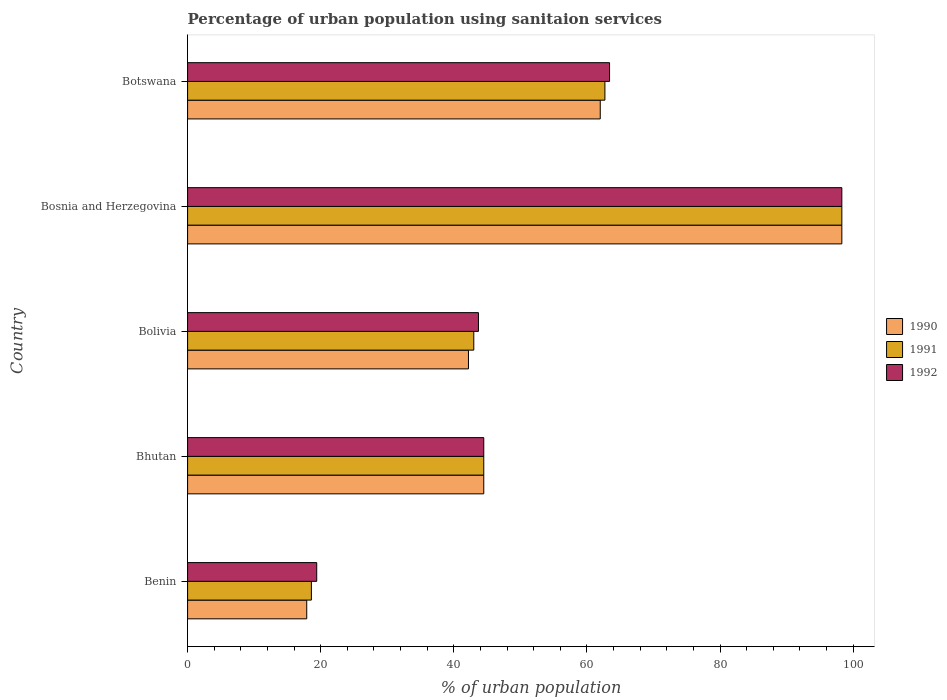How many different coloured bars are there?
Give a very brief answer. 3. Are the number of bars per tick equal to the number of legend labels?
Offer a terse response. Yes. Are the number of bars on each tick of the Y-axis equal?
Your response must be concise. Yes. How many bars are there on the 5th tick from the top?
Your answer should be very brief. 3. How many bars are there on the 2nd tick from the bottom?
Offer a very short reply. 3. What is the label of the 2nd group of bars from the top?
Give a very brief answer. Bosnia and Herzegovina. In how many cases, is the number of bars for a given country not equal to the number of legend labels?
Provide a succinct answer. 0. What is the percentage of urban population using sanitaion services in 1992 in Bosnia and Herzegovina?
Provide a succinct answer. 98.3. Across all countries, what is the maximum percentage of urban population using sanitaion services in 1992?
Your response must be concise. 98.3. Across all countries, what is the minimum percentage of urban population using sanitaion services in 1990?
Offer a very short reply. 17.9. In which country was the percentage of urban population using sanitaion services in 1990 maximum?
Offer a very short reply. Bosnia and Herzegovina. In which country was the percentage of urban population using sanitaion services in 1990 minimum?
Make the answer very short. Benin. What is the total percentage of urban population using sanitaion services in 1990 in the graph?
Provide a succinct answer. 264.9. What is the difference between the percentage of urban population using sanitaion services in 1992 in Bosnia and Herzegovina and that in Botswana?
Make the answer very short. 34.9. What is the difference between the percentage of urban population using sanitaion services in 1990 in Bolivia and the percentage of urban population using sanitaion services in 1992 in Botswana?
Ensure brevity in your answer.  -21.2. What is the average percentage of urban population using sanitaion services in 1992 per country?
Offer a terse response. 53.86. What is the difference between the percentage of urban population using sanitaion services in 1992 and percentage of urban population using sanitaion services in 1991 in Bolivia?
Give a very brief answer. 0.7. What is the ratio of the percentage of urban population using sanitaion services in 1990 in Bolivia to that in Bosnia and Herzegovina?
Provide a succinct answer. 0.43. Is the percentage of urban population using sanitaion services in 1990 in Bolivia less than that in Botswana?
Your answer should be compact. Yes. Is the difference between the percentage of urban population using sanitaion services in 1992 in Bhutan and Bolivia greater than the difference between the percentage of urban population using sanitaion services in 1991 in Bhutan and Bolivia?
Offer a terse response. No. What is the difference between the highest and the second highest percentage of urban population using sanitaion services in 1992?
Provide a succinct answer. 34.9. What is the difference between the highest and the lowest percentage of urban population using sanitaion services in 1991?
Provide a succinct answer. 79.7. In how many countries, is the percentage of urban population using sanitaion services in 1990 greater than the average percentage of urban population using sanitaion services in 1990 taken over all countries?
Make the answer very short. 2. What does the 2nd bar from the top in Botswana represents?
Ensure brevity in your answer.  1991. What does the 3rd bar from the bottom in Bolivia represents?
Your answer should be compact. 1992. How many bars are there?
Give a very brief answer. 15. Are all the bars in the graph horizontal?
Offer a very short reply. Yes. What is the difference between two consecutive major ticks on the X-axis?
Keep it short and to the point. 20. Does the graph contain grids?
Keep it short and to the point. No. Where does the legend appear in the graph?
Your answer should be very brief. Center right. How are the legend labels stacked?
Give a very brief answer. Vertical. What is the title of the graph?
Offer a very short reply. Percentage of urban population using sanitaion services. Does "2011" appear as one of the legend labels in the graph?
Offer a terse response. No. What is the label or title of the X-axis?
Keep it short and to the point. % of urban population. What is the label or title of the Y-axis?
Your response must be concise. Country. What is the % of urban population in 1992 in Benin?
Provide a succinct answer. 19.4. What is the % of urban population in 1990 in Bhutan?
Give a very brief answer. 44.5. What is the % of urban population in 1991 in Bhutan?
Offer a terse response. 44.5. What is the % of urban population in 1992 in Bhutan?
Provide a succinct answer. 44.5. What is the % of urban population of 1990 in Bolivia?
Provide a succinct answer. 42.2. What is the % of urban population of 1991 in Bolivia?
Make the answer very short. 43. What is the % of urban population in 1992 in Bolivia?
Provide a short and direct response. 43.7. What is the % of urban population in 1990 in Bosnia and Herzegovina?
Keep it short and to the point. 98.3. What is the % of urban population in 1991 in Bosnia and Herzegovina?
Make the answer very short. 98.3. What is the % of urban population in 1992 in Bosnia and Herzegovina?
Provide a short and direct response. 98.3. What is the % of urban population of 1991 in Botswana?
Offer a very short reply. 62.7. What is the % of urban population in 1992 in Botswana?
Keep it short and to the point. 63.4. Across all countries, what is the maximum % of urban population in 1990?
Provide a short and direct response. 98.3. Across all countries, what is the maximum % of urban population in 1991?
Your answer should be very brief. 98.3. Across all countries, what is the maximum % of urban population of 1992?
Keep it short and to the point. 98.3. What is the total % of urban population of 1990 in the graph?
Provide a short and direct response. 264.9. What is the total % of urban population of 1991 in the graph?
Give a very brief answer. 267.1. What is the total % of urban population in 1992 in the graph?
Your answer should be very brief. 269.3. What is the difference between the % of urban population in 1990 in Benin and that in Bhutan?
Ensure brevity in your answer.  -26.6. What is the difference between the % of urban population in 1991 in Benin and that in Bhutan?
Your answer should be very brief. -25.9. What is the difference between the % of urban population of 1992 in Benin and that in Bhutan?
Make the answer very short. -25.1. What is the difference between the % of urban population of 1990 in Benin and that in Bolivia?
Ensure brevity in your answer.  -24.3. What is the difference between the % of urban population of 1991 in Benin and that in Bolivia?
Your answer should be compact. -24.4. What is the difference between the % of urban population in 1992 in Benin and that in Bolivia?
Offer a terse response. -24.3. What is the difference between the % of urban population of 1990 in Benin and that in Bosnia and Herzegovina?
Give a very brief answer. -80.4. What is the difference between the % of urban population in 1991 in Benin and that in Bosnia and Herzegovina?
Keep it short and to the point. -79.7. What is the difference between the % of urban population of 1992 in Benin and that in Bosnia and Herzegovina?
Your response must be concise. -78.9. What is the difference between the % of urban population in 1990 in Benin and that in Botswana?
Give a very brief answer. -44.1. What is the difference between the % of urban population in 1991 in Benin and that in Botswana?
Ensure brevity in your answer.  -44.1. What is the difference between the % of urban population of 1992 in Benin and that in Botswana?
Offer a very short reply. -44. What is the difference between the % of urban population in 1990 in Bhutan and that in Bolivia?
Your answer should be compact. 2.3. What is the difference between the % of urban population in 1991 in Bhutan and that in Bolivia?
Give a very brief answer. 1.5. What is the difference between the % of urban population of 1990 in Bhutan and that in Bosnia and Herzegovina?
Your response must be concise. -53.8. What is the difference between the % of urban population of 1991 in Bhutan and that in Bosnia and Herzegovina?
Offer a very short reply. -53.8. What is the difference between the % of urban population of 1992 in Bhutan and that in Bosnia and Herzegovina?
Give a very brief answer. -53.8. What is the difference between the % of urban population in 1990 in Bhutan and that in Botswana?
Your response must be concise. -17.5. What is the difference between the % of urban population of 1991 in Bhutan and that in Botswana?
Make the answer very short. -18.2. What is the difference between the % of urban population in 1992 in Bhutan and that in Botswana?
Provide a short and direct response. -18.9. What is the difference between the % of urban population of 1990 in Bolivia and that in Bosnia and Herzegovina?
Offer a very short reply. -56.1. What is the difference between the % of urban population in 1991 in Bolivia and that in Bosnia and Herzegovina?
Your response must be concise. -55.3. What is the difference between the % of urban population of 1992 in Bolivia and that in Bosnia and Herzegovina?
Make the answer very short. -54.6. What is the difference between the % of urban population of 1990 in Bolivia and that in Botswana?
Give a very brief answer. -19.8. What is the difference between the % of urban population in 1991 in Bolivia and that in Botswana?
Make the answer very short. -19.7. What is the difference between the % of urban population in 1992 in Bolivia and that in Botswana?
Make the answer very short. -19.7. What is the difference between the % of urban population in 1990 in Bosnia and Herzegovina and that in Botswana?
Offer a very short reply. 36.3. What is the difference between the % of urban population of 1991 in Bosnia and Herzegovina and that in Botswana?
Provide a short and direct response. 35.6. What is the difference between the % of urban population in 1992 in Bosnia and Herzegovina and that in Botswana?
Give a very brief answer. 34.9. What is the difference between the % of urban population in 1990 in Benin and the % of urban population in 1991 in Bhutan?
Ensure brevity in your answer.  -26.6. What is the difference between the % of urban population of 1990 in Benin and the % of urban population of 1992 in Bhutan?
Offer a terse response. -26.6. What is the difference between the % of urban population of 1991 in Benin and the % of urban population of 1992 in Bhutan?
Give a very brief answer. -25.9. What is the difference between the % of urban population of 1990 in Benin and the % of urban population of 1991 in Bolivia?
Your response must be concise. -25.1. What is the difference between the % of urban population in 1990 in Benin and the % of urban population in 1992 in Bolivia?
Your answer should be compact. -25.8. What is the difference between the % of urban population of 1991 in Benin and the % of urban population of 1992 in Bolivia?
Provide a succinct answer. -25.1. What is the difference between the % of urban population in 1990 in Benin and the % of urban population in 1991 in Bosnia and Herzegovina?
Your answer should be compact. -80.4. What is the difference between the % of urban population of 1990 in Benin and the % of urban population of 1992 in Bosnia and Herzegovina?
Provide a succinct answer. -80.4. What is the difference between the % of urban population in 1991 in Benin and the % of urban population in 1992 in Bosnia and Herzegovina?
Your answer should be very brief. -79.7. What is the difference between the % of urban population of 1990 in Benin and the % of urban population of 1991 in Botswana?
Provide a short and direct response. -44.8. What is the difference between the % of urban population of 1990 in Benin and the % of urban population of 1992 in Botswana?
Your answer should be compact. -45.5. What is the difference between the % of urban population of 1991 in Benin and the % of urban population of 1992 in Botswana?
Provide a short and direct response. -44.8. What is the difference between the % of urban population in 1990 in Bhutan and the % of urban population in 1991 in Bolivia?
Make the answer very short. 1.5. What is the difference between the % of urban population of 1990 in Bhutan and the % of urban population of 1992 in Bolivia?
Offer a very short reply. 0.8. What is the difference between the % of urban population in 1991 in Bhutan and the % of urban population in 1992 in Bolivia?
Offer a terse response. 0.8. What is the difference between the % of urban population in 1990 in Bhutan and the % of urban population in 1991 in Bosnia and Herzegovina?
Provide a short and direct response. -53.8. What is the difference between the % of urban population in 1990 in Bhutan and the % of urban population in 1992 in Bosnia and Herzegovina?
Offer a terse response. -53.8. What is the difference between the % of urban population in 1991 in Bhutan and the % of urban population in 1992 in Bosnia and Herzegovina?
Keep it short and to the point. -53.8. What is the difference between the % of urban population in 1990 in Bhutan and the % of urban population in 1991 in Botswana?
Provide a short and direct response. -18.2. What is the difference between the % of urban population of 1990 in Bhutan and the % of urban population of 1992 in Botswana?
Give a very brief answer. -18.9. What is the difference between the % of urban population of 1991 in Bhutan and the % of urban population of 1992 in Botswana?
Provide a short and direct response. -18.9. What is the difference between the % of urban population in 1990 in Bolivia and the % of urban population in 1991 in Bosnia and Herzegovina?
Your response must be concise. -56.1. What is the difference between the % of urban population of 1990 in Bolivia and the % of urban population of 1992 in Bosnia and Herzegovina?
Your response must be concise. -56.1. What is the difference between the % of urban population of 1991 in Bolivia and the % of urban population of 1992 in Bosnia and Herzegovina?
Offer a very short reply. -55.3. What is the difference between the % of urban population in 1990 in Bolivia and the % of urban population in 1991 in Botswana?
Offer a terse response. -20.5. What is the difference between the % of urban population of 1990 in Bolivia and the % of urban population of 1992 in Botswana?
Make the answer very short. -21.2. What is the difference between the % of urban population of 1991 in Bolivia and the % of urban population of 1992 in Botswana?
Offer a very short reply. -20.4. What is the difference between the % of urban population in 1990 in Bosnia and Herzegovina and the % of urban population in 1991 in Botswana?
Offer a very short reply. 35.6. What is the difference between the % of urban population in 1990 in Bosnia and Herzegovina and the % of urban population in 1992 in Botswana?
Offer a terse response. 34.9. What is the difference between the % of urban population of 1991 in Bosnia and Herzegovina and the % of urban population of 1992 in Botswana?
Your response must be concise. 34.9. What is the average % of urban population of 1990 per country?
Your response must be concise. 52.98. What is the average % of urban population in 1991 per country?
Give a very brief answer. 53.42. What is the average % of urban population of 1992 per country?
Give a very brief answer. 53.86. What is the difference between the % of urban population of 1990 and % of urban population of 1992 in Benin?
Ensure brevity in your answer.  -1.5. What is the difference between the % of urban population in 1990 and % of urban population in 1991 in Bhutan?
Provide a succinct answer. 0. What is the difference between the % of urban population in 1990 and % of urban population in 1992 in Bhutan?
Give a very brief answer. 0. What is the difference between the % of urban population in 1991 and % of urban population in 1992 in Bhutan?
Your response must be concise. 0. What is the difference between the % of urban population in 1990 and % of urban population in 1992 in Bolivia?
Provide a short and direct response. -1.5. What is the difference between the % of urban population in 1990 and % of urban population in 1992 in Bosnia and Herzegovina?
Give a very brief answer. 0. What is the difference between the % of urban population in 1990 and % of urban population in 1991 in Botswana?
Ensure brevity in your answer.  -0.7. What is the difference between the % of urban population of 1990 and % of urban population of 1992 in Botswana?
Keep it short and to the point. -1.4. What is the ratio of the % of urban population in 1990 in Benin to that in Bhutan?
Offer a terse response. 0.4. What is the ratio of the % of urban population of 1991 in Benin to that in Bhutan?
Your answer should be very brief. 0.42. What is the ratio of the % of urban population in 1992 in Benin to that in Bhutan?
Keep it short and to the point. 0.44. What is the ratio of the % of urban population of 1990 in Benin to that in Bolivia?
Make the answer very short. 0.42. What is the ratio of the % of urban population in 1991 in Benin to that in Bolivia?
Provide a short and direct response. 0.43. What is the ratio of the % of urban population of 1992 in Benin to that in Bolivia?
Provide a succinct answer. 0.44. What is the ratio of the % of urban population in 1990 in Benin to that in Bosnia and Herzegovina?
Keep it short and to the point. 0.18. What is the ratio of the % of urban population of 1991 in Benin to that in Bosnia and Herzegovina?
Make the answer very short. 0.19. What is the ratio of the % of urban population of 1992 in Benin to that in Bosnia and Herzegovina?
Ensure brevity in your answer.  0.2. What is the ratio of the % of urban population in 1990 in Benin to that in Botswana?
Make the answer very short. 0.29. What is the ratio of the % of urban population of 1991 in Benin to that in Botswana?
Provide a succinct answer. 0.3. What is the ratio of the % of urban population in 1992 in Benin to that in Botswana?
Provide a short and direct response. 0.31. What is the ratio of the % of urban population in 1990 in Bhutan to that in Bolivia?
Ensure brevity in your answer.  1.05. What is the ratio of the % of urban population of 1991 in Bhutan to that in Bolivia?
Keep it short and to the point. 1.03. What is the ratio of the % of urban population in 1992 in Bhutan to that in Bolivia?
Offer a terse response. 1.02. What is the ratio of the % of urban population of 1990 in Bhutan to that in Bosnia and Herzegovina?
Give a very brief answer. 0.45. What is the ratio of the % of urban population in 1991 in Bhutan to that in Bosnia and Herzegovina?
Provide a succinct answer. 0.45. What is the ratio of the % of urban population of 1992 in Bhutan to that in Bosnia and Herzegovina?
Keep it short and to the point. 0.45. What is the ratio of the % of urban population in 1990 in Bhutan to that in Botswana?
Offer a very short reply. 0.72. What is the ratio of the % of urban population of 1991 in Bhutan to that in Botswana?
Provide a short and direct response. 0.71. What is the ratio of the % of urban population in 1992 in Bhutan to that in Botswana?
Your answer should be very brief. 0.7. What is the ratio of the % of urban population of 1990 in Bolivia to that in Bosnia and Herzegovina?
Keep it short and to the point. 0.43. What is the ratio of the % of urban population of 1991 in Bolivia to that in Bosnia and Herzegovina?
Keep it short and to the point. 0.44. What is the ratio of the % of urban population of 1992 in Bolivia to that in Bosnia and Herzegovina?
Provide a short and direct response. 0.44. What is the ratio of the % of urban population in 1990 in Bolivia to that in Botswana?
Your response must be concise. 0.68. What is the ratio of the % of urban population of 1991 in Bolivia to that in Botswana?
Keep it short and to the point. 0.69. What is the ratio of the % of urban population of 1992 in Bolivia to that in Botswana?
Give a very brief answer. 0.69. What is the ratio of the % of urban population in 1990 in Bosnia and Herzegovina to that in Botswana?
Your answer should be compact. 1.59. What is the ratio of the % of urban population in 1991 in Bosnia and Herzegovina to that in Botswana?
Your answer should be compact. 1.57. What is the ratio of the % of urban population in 1992 in Bosnia and Herzegovina to that in Botswana?
Provide a succinct answer. 1.55. What is the difference between the highest and the second highest % of urban population in 1990?
Give a very brief answer. 36.3. What is the difference between the highest and the second highest % of urban population of 1991?
Offer a very short reply. 35.6. What is the difference between the highest and the second highest % of urban population in 1992?
Ensure brevity in your answer.  34.9. What is the difference between the highest and the lowest % of urban population of 1990?
Provide a short and direct response. 80.4. What is the difference between the highest and the lowest % of urban population of 1991?
Give a very brief answer. 79.7. What is the difference between the highest and the lowest % of urban population of 1992?
Provide a succinct answer. 78.9. 